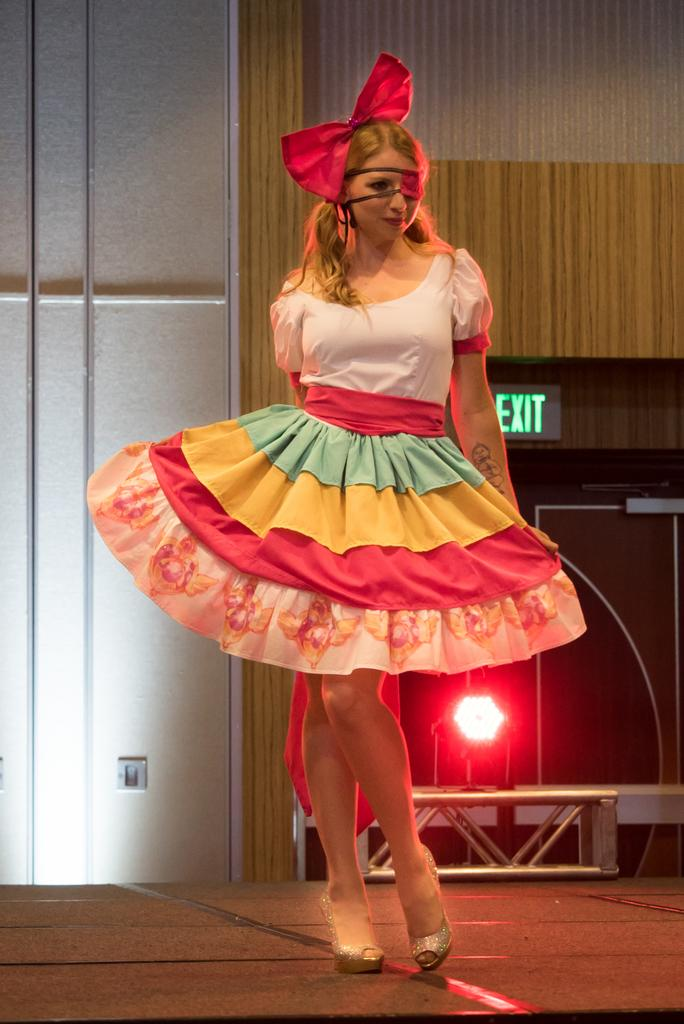Who is the main subject in the image? There is a girl in the image. What is the girl wearing? The girl is wearing a frock. What object can be seen in the image besides the girl? There is a speaker in the image. What type of lighting is present in the image? There is a red color light in the image. What can be seen in the background of the image? There is a wall in the background of the image. How much does the girl's muscle weigh in the image? There is no information about the girl's muscle weight in the image. 